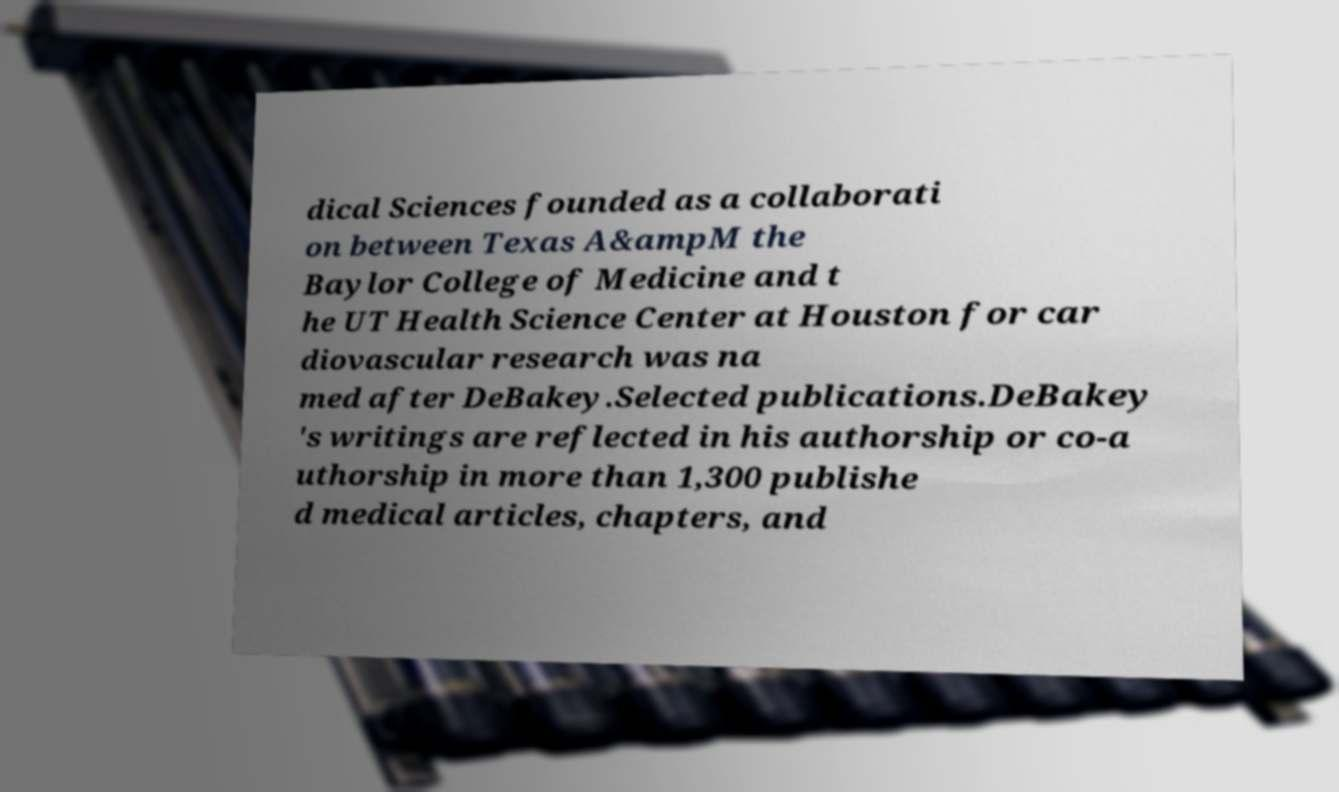Can you accurately transcribe the text from the provided image for me? dical Sciences founded as a collaborati on between Texas A&ampM the Baylor College of Medicine and t he UT Health Science Center at Houston for car diovascular research was na med after DeBakey.Selected publications.DeBakey 's writings are reflected in his authorship or co-a uthorship in more than 1,300 publishe d medical articles, chapters, and 